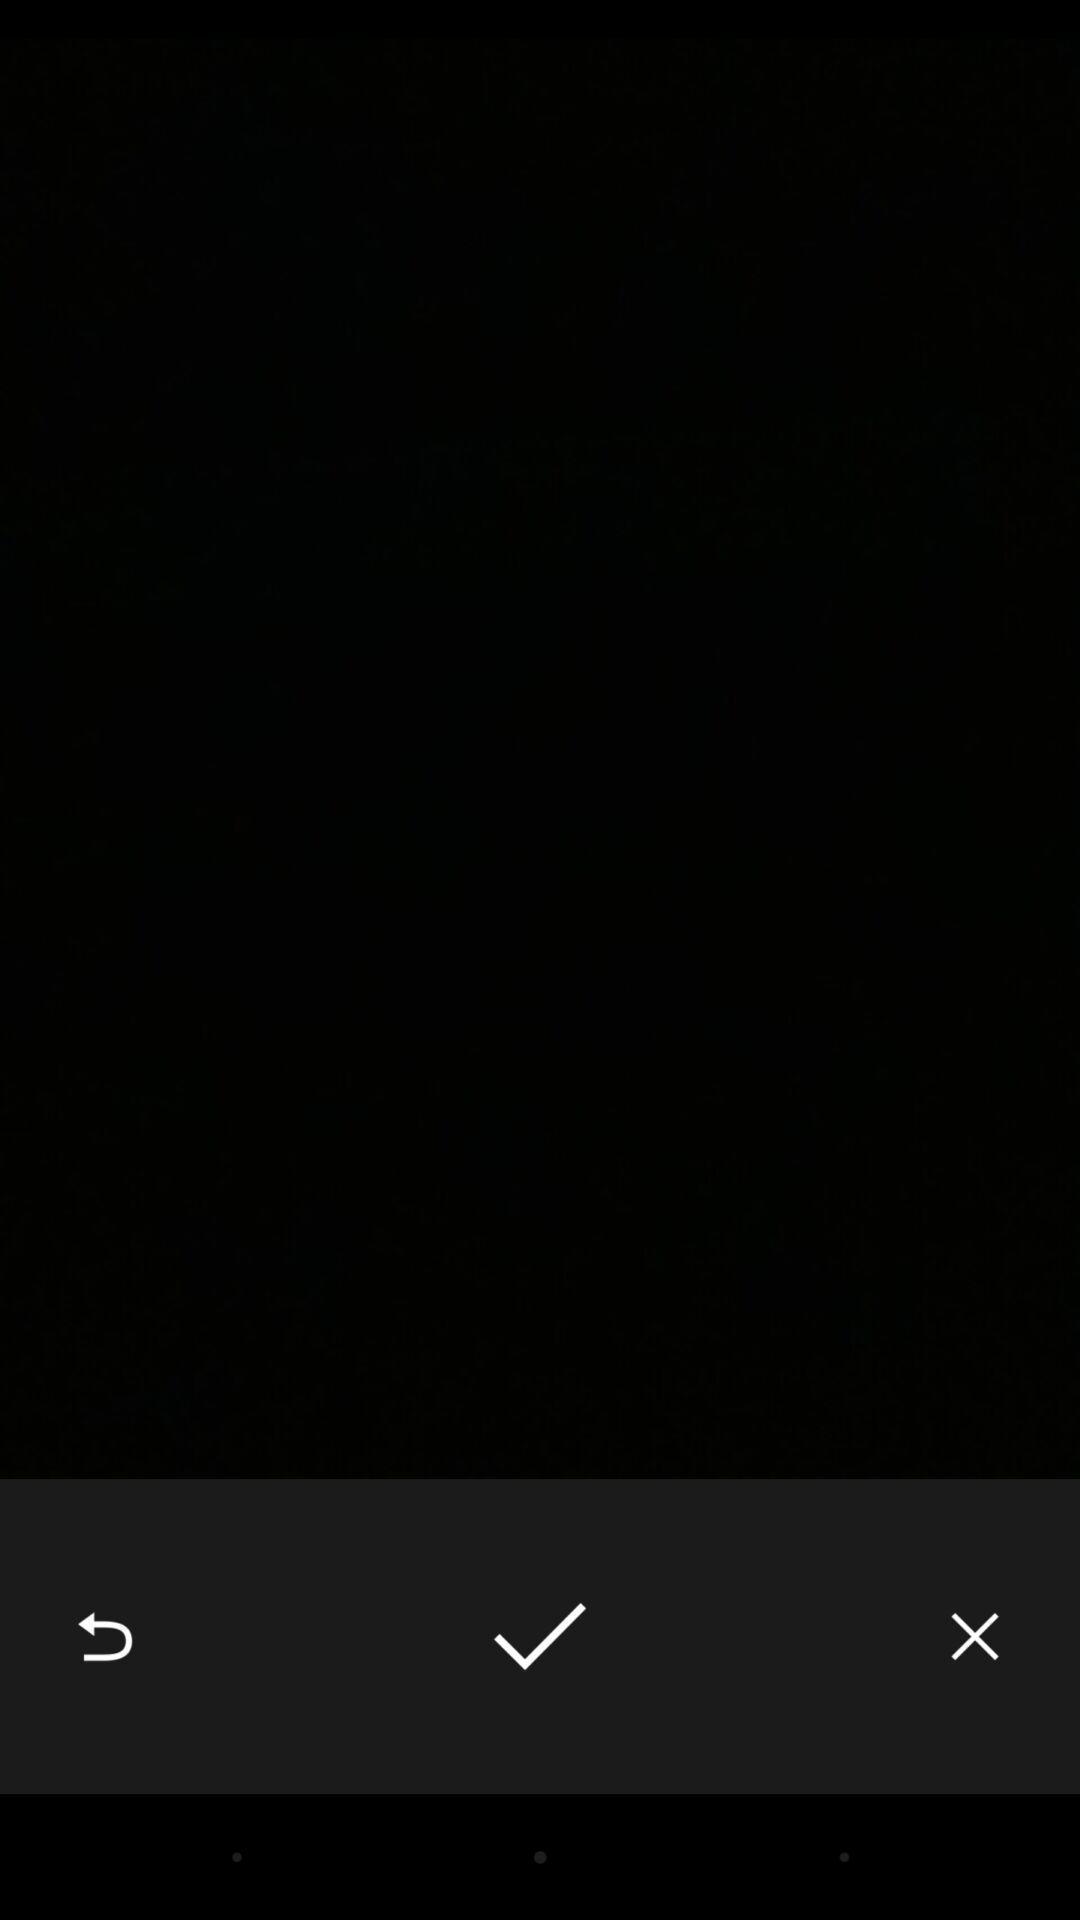Explain what's happening in this screen capture. Screen shows a blank page. 